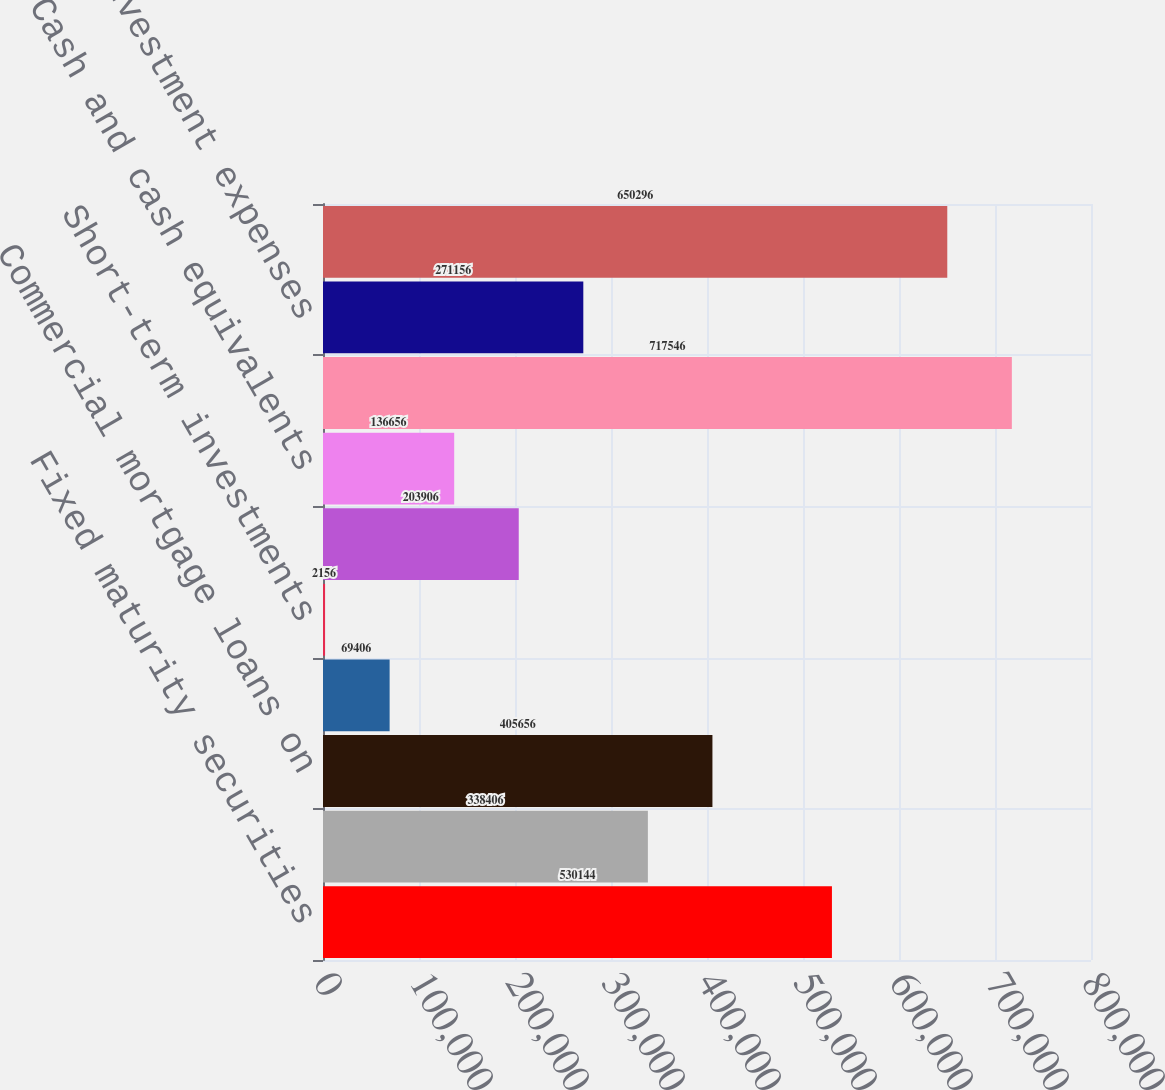Convert chart to OTSL. <chart><loc_0><loc_0><loc_500><loc_500><bar_chart><fcel>Fixed maturity securities<fcel>Equity securities<fcel>Commercial mortgage loans on<fcel>Policy loans<fcel>Short-term investments<fcel>Other investments<fcel>Cash and cash equivalents<fcel>Total investment income<fcel>Investment expenses<fcel>NET INVESTMENT INCOME<nl><fcel>530144<fcel>338406<fcel>405656<fcel>69406<fcel>2156<fcel>203906<fcel>136656<fcel>717546<fcel>271156<fcel>650296<nl></chart> 